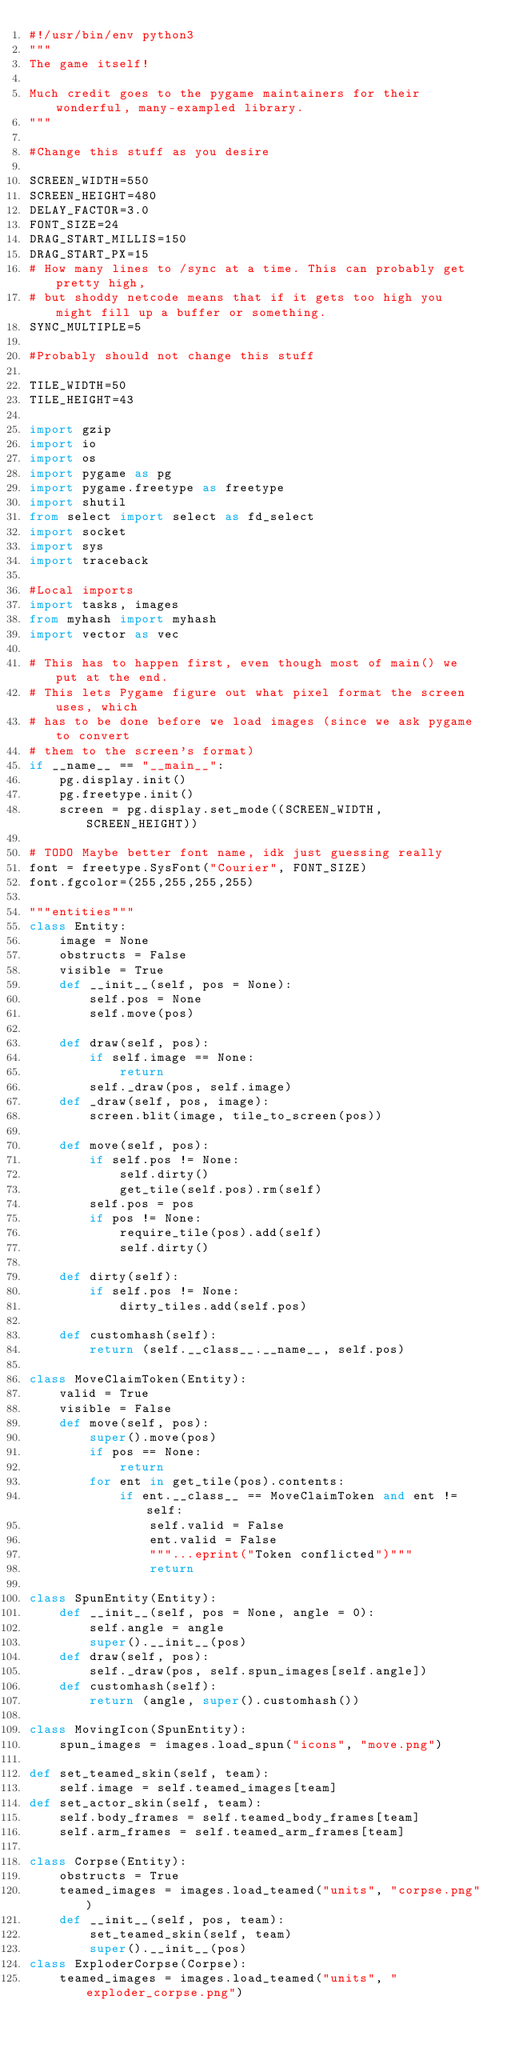<code> <loc_0><loc_0><loc_500><loc_500><_Python_>#!/usr/bin/env python3
"""
The game itself!

Much credit goes to the pygame maintainers for their wonderful, many-exampled library.
"""

#Change this stuff as you desire

SCREEN_WIDTH=550
SCREEN_HEIGHT=480
DELAY_FACTOR=3.0
FONT_SIZE=24
DRAG_START_MILLIS=150
DRAG_START_PX=15
# How many lines to /sync at a time. This can probably get pretty high,
# but shoddy netcode means that if it gets too high you might fill up a buffer or something.
SYNC_MULTIPLE=5

#Probably should not change this stuff

TILE_WIDTH=50
TILE_HEIGHT=43

import gzip
import io
import os
import pygame as pg
import pygame.freetype as freetype
import shutil
from select import select as fd_select
import socket
import sys
import traceback

#Local imports
import tasks, images
from myhash import myhash
import vector as vec

# This has to happen first, even though most of main() we put at the end.
# This lets Pygame figure out what pixel format the screen uses, which
# has to be done before we load images (since we ask pygame to convert
# them to the screen's format)
if __name__ == "__main__":
    pg.display.init()
    pg.freetype.init()
    screen = pg.display.set_mode((SCREEN_WIDTH, SCREEN_HEIGHT))

# TODO Maybe better font name, idk just guessing really
font = freetype.SysFont("Courier", FONT_SIZE)
font.fgcolor=(255,255,255,255)

"""entities"""
class Entity:
    image = None
    obstructs = False
    visible = True
    def __init__(self, pos = None):
        self.pos = None
        self.move(pos)

    def draw(self, pos):
        if self.image == None:
            return
        self._draw(pos, self.image)
    def _draw(self, pos, image):
        screen.blit(image, tile_to_screen(pos))

    def move(self, pos):
        if self.pos != None:
            self.dirty()
            get_tile(self.pos).rm(self)
        self.pos = pos
        if pos != None:
            require_tile(pos).add(self)
            self.dirty()

    def dirty(self):
        if self.pos != None:
            dirty_tiles.add(self.pos)

    def customhash(self):
        return (self.__class__.__name__, self.pos)

class MoveClaimToken(Entity):
    valid = True
    visible = False
    def move(self, pos):
        super().move(pos)
        if pos == None:
            return
        for ent in get_tile(pos).contents:
            if ent.__class__ == MoveClaimToken and ent != self:
                self.valid = False
                ent.valid = False
                """...eprint("Token conflicted")"""
                return

class SpunEntity(Entity):
    def __init__(self, pos = None, angle = 0):
        self.angle = angle
        super().__init__(pos)
    def draw(self, pos):
        self._draw(pos, self.spun_images[self.angle])
    def customhash(self):
        return (angle, super().customhash())

class MovingIcon(SpunEntity):
    spun_images = images.load_spun("icons", "move.png")

def set_teamed_skin(self, team):
    self.image = self.teamed_images[team]
def set_actor_skin(self, team):
    self.body_frames = self.teamed_body_frames[team]
    self.arm_frames = self.teamed_arm_frames[team]

class Corpse(Entity):
    obstructs = True
    teamed_images = images.load_teamed("units", "corpse.png")
    def __init__(self, pos, team):
        set_teamed_skin(self, team)
        super().__init__(pos)
class ExploderCorpse(Corpse):
    teamed_images = images.load_teamed("units", "exploder_corpse.png")
</code> 